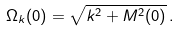<formula> <loc_0><loc_0><loc_500><loc_500>\Omega _ { k } ( 0 ) = \sqrt { k ^ { 2 } + M ^ { 2 } ( 0 ) } \, .</formula> 